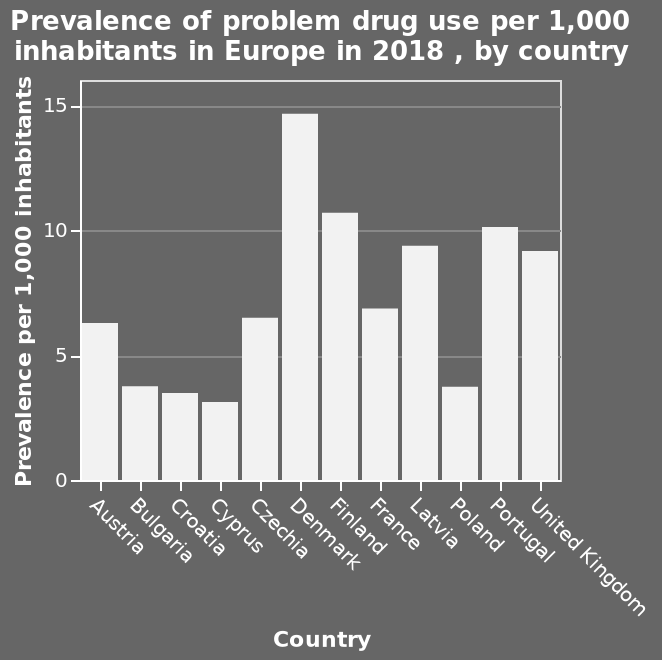<image>
please describe the details of the chart This is a bar plot labeled Prevalence of problem drug use per 1,000 inhabitants in Europe in 2018 , by country. The y-axis measures Prevalence per 1,000 inhabitants while the x-axis measures Country. please summary the statistics and relations of the chart In the bar chat the prevalence of problem drug use per 1,000 inhabitants in Europe in 2018 , by country is shown. At first sight of the graph it is clear that the Country with the biggest problem drug use is Denmark that is significantly higher than the other European countries displayed. Portugal Finland and Latvia all seem significantly high also despite not trailing infant of Denmark. And we can also see the Cyprus has the least problem with drug use despite still having a number on the chart. 